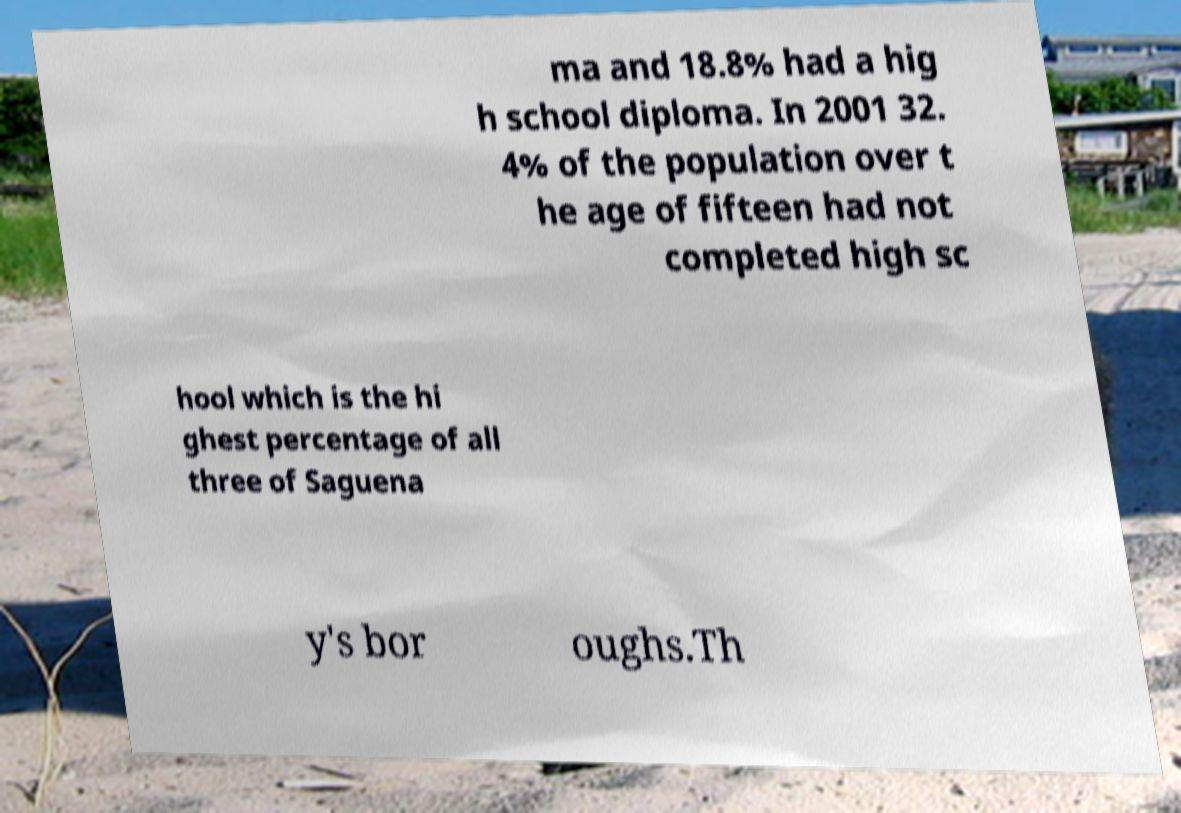Please read and relay the text visible in this image. What does it say? ma and 18.8% had a hig h school diploma. In 2001 32. 4% of the population over t he age of fifteen had not completed high sc hool which is the hi ghest percentage of all three of Saguena y's bor oughs.Th 